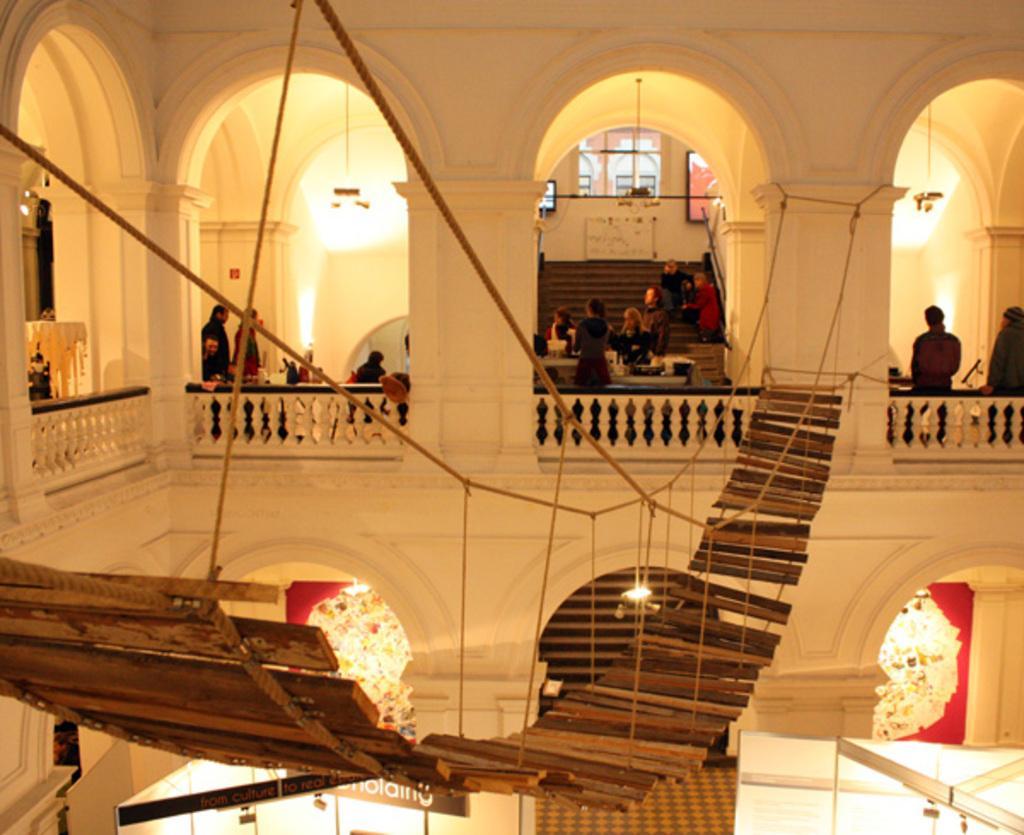How would you summarize this image in a sentence or two? It is an inside view of a building. Here we can see wooden objects, ropes, railings, few people, pillars, stairs, lights, floor, banners, walls and screen. Few people are standing and sitting. 